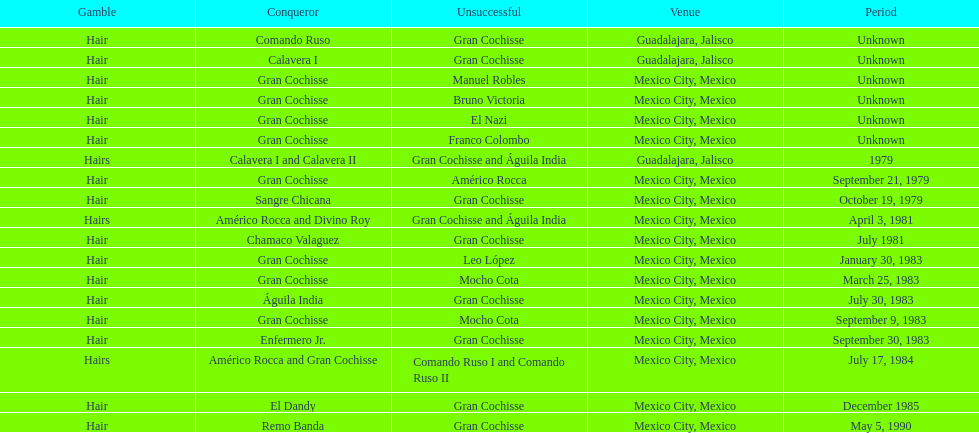How many times has gran cochisse been a winner? 9. 